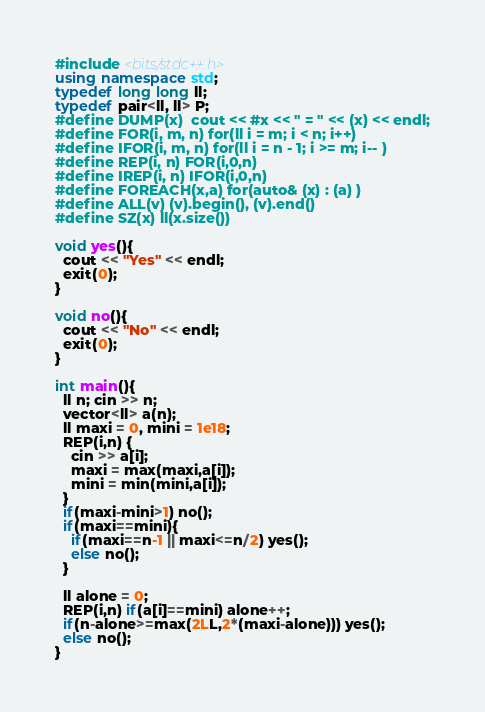Convert code to text. <code><loc_0><loc_0><loc_500><loc_500><_C++_>#include <bits/stdc++.h>
using namespace std;
typedef long long ll;
typedef pair<ll, ll> P;
#define DUMP(x)  cout << #x << " = " << (x) << endl;
#define FOR(i, m, n) for(ll i = m; i < n; i++)
#define IFOR(i, m, n) for(ll i = n - 1; i >= m; i-- )
#define REP(i, n) FOR(i,0,n)
#define IREP(i, n) IFOR(i,0,n)
#define FOREACH(x,a) for(auto& (x) : (a) )
#define ALL(v) (v).begin(), (v).end()
#define SZ(x) ll(x.size())

void yes(){
  cout << "Yes" << endl;
  exit(0);
}

void no(){
  cout << "No" << endl;
  exit(0);
}

int main(){
  ll n; cin >> n;
  vector<ll> a(n);
  ll maxi = 0, mini = 1e18;
  REP(i,n) {
    cin >> a[i];
    maxi = max(maxi,a[i]);
    mini = min(mini,a[i]);
  }
  if(maxi-mini>1) no();
  if(maxi==mini){
    if(maxi==n-1 || maxi<=n/2) yes();
    else no();
  }
  
  ll alone = 0;
  REP(i,n) if(a[i]==mini) alone++;
  if(n-alone>=max(2LL,2*(maxi-alone))) yes();
  else no();
}</code> 